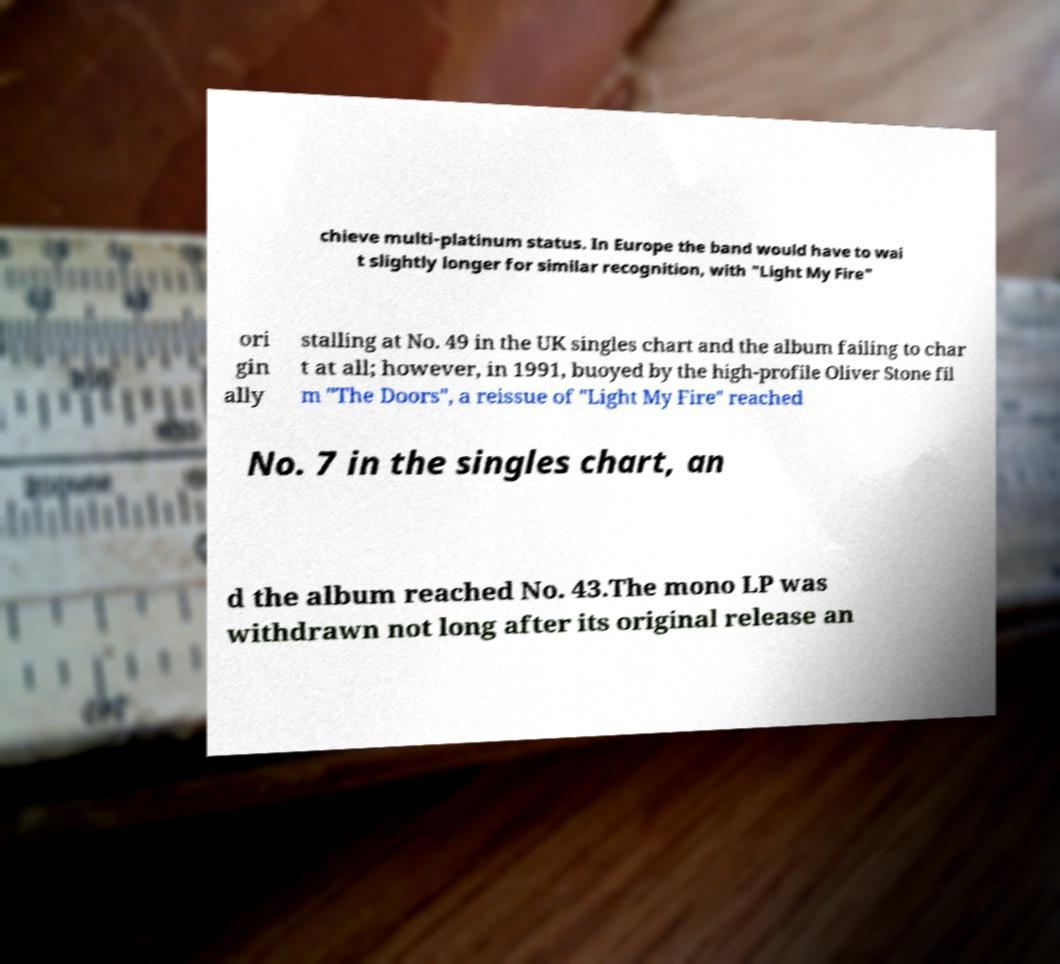Please read and relay the text visible in this image. What does it say? chieve multi-platinum status. In Europe the band would have to wai t slightly longer for similar recognition, with "Light My Fire" ori gin ally stalling at No. 49 in the UK singles chart and the album failing to char t at all; however, in 1991, buoyed by the high-profile Oliver Stone fil m "The Doors", a reissue of "Light My Fire" reached No. 7 in the singles chart, an d the album reached No. 43.The mono LP was withdrawn not long after its original release an 